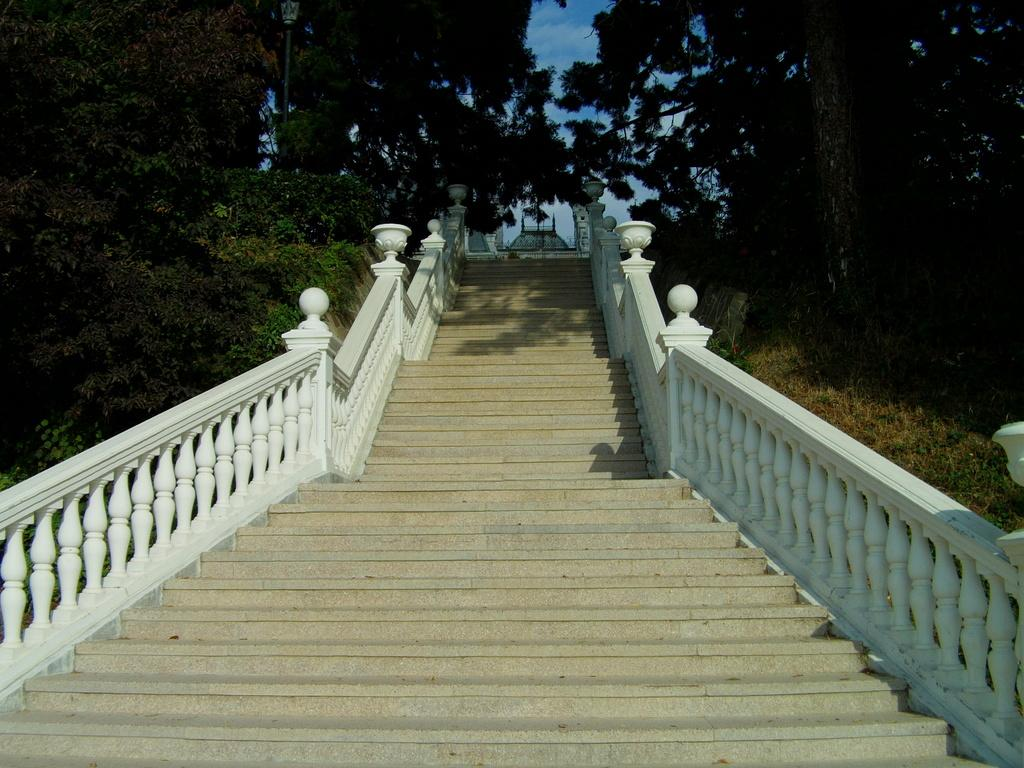What type of structure is visible in the image? There are stairs in the image. What feature is present to provide safety while using the stairs? There are railings around the stairs. What type of vegetation is near the stairs? Plants are present near the stairs. What type of ground surface is visible in the image? Grass is visible in the image. What other type of vegetation is present in the image? Trees are present in the image. What type of whip is being used to control the tax in the image? There is no whip, tax, or any related activity present in the image. 